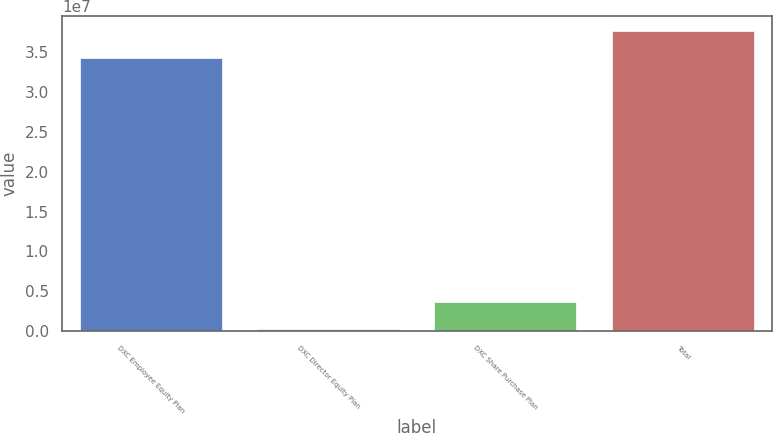<chart> <loc_0><loc_0><loc_500><loc_500><bar_chart><fcel>DXC Employee Equity Plan<fcel>DXC Director Equity Plan<fcel>DXC Share Purchase Plan<fcel>Total<nl><fcel>3.42e+07<fcel>230000<fcel>3.675e+06<fcel>3.7645e+07<nl></chart> 